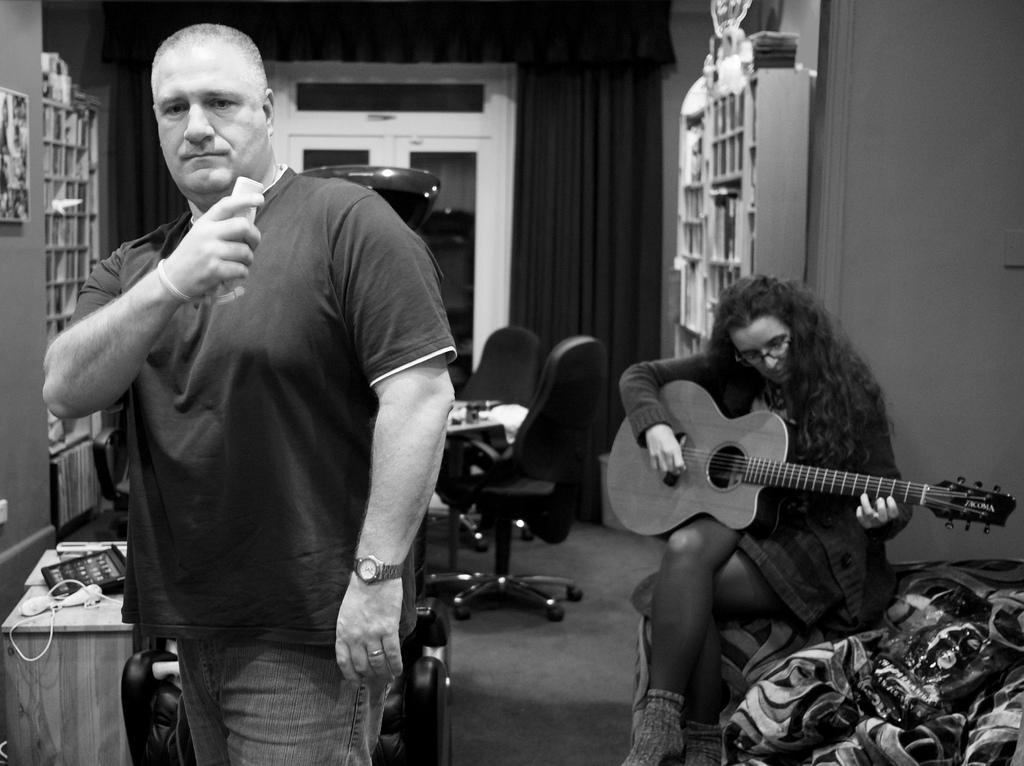What is the man doing in the image? The man is standing in the image. What is the woman doing in the image? The woman is sitting and playing a guitar in the image. What can be seen in the background of the image? There are chairs, a curtain, a door, a bookshelf, and a table in the background of the image. What type of face cream is the woman applying in the image? There is no face cream or any indication of the woman applying anything to her face in the image. What effect does the guitar have on the man in the image? The image does not show any effect of the guitar on the man, as he is simply standing and not interacting with the woman or her guitar. 